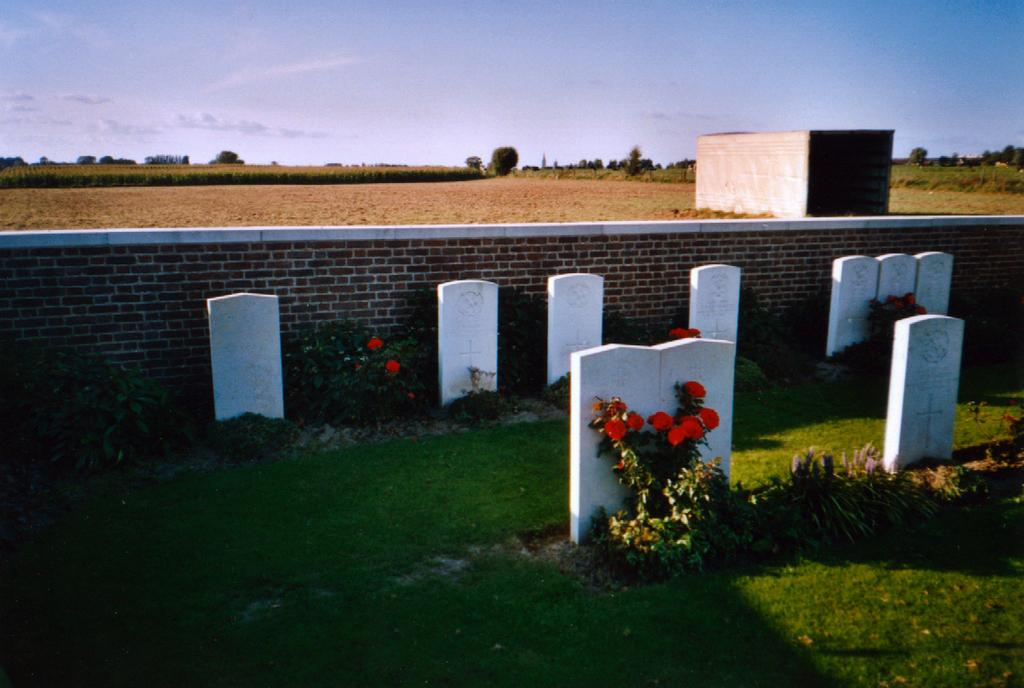What is the main subject in the center of the image? There is a graveyard in the center of the image. What type of vegetation is present at the bottom of the image? There is grass at the bottom of the image. What can be seen in the background of the image? There is a wall, a building, land, plants, trees, and the sky visible in the background of the image. Can you describe the sky in the image? The sky is visible in the background of the image, and there is a cloud present. What invention is being demonstrated by the dad in the image? There is no dad or invention present in the image; it features a graveyard and various background elements. 